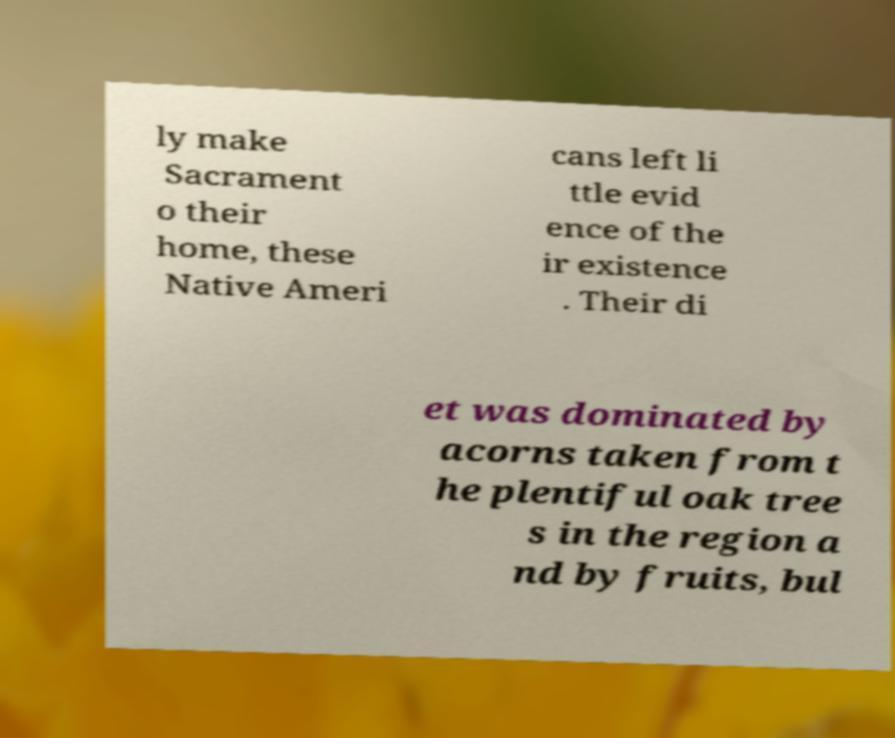For documentation purposes, I need the text within this image transcribed. Could you provide that? ly make Sacrament o their home, these Native Ameri cans left li ttle evid ence of the ir existence . Their di et was dominated by acorns taken from t he plentiful oak tree s in the region a nd by fruits, bul 